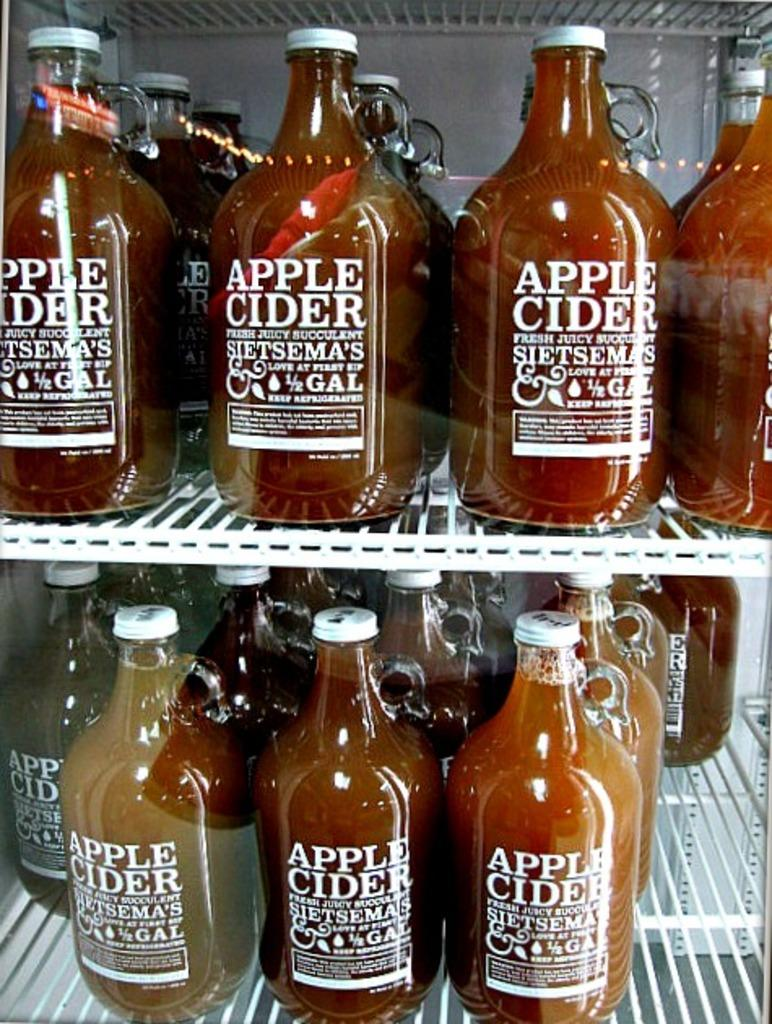Provide a one-sentence caption for the provided image. A large walk in fridge is full of large bottles of Sietsema's Apple Cider. 